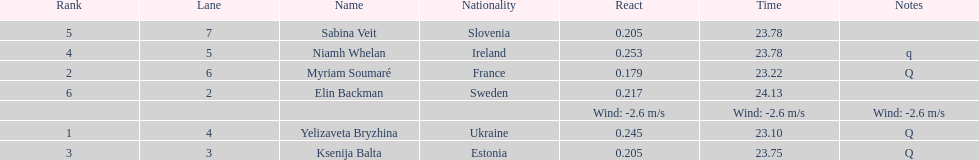Would you mind parsing the complete table? {'header': ['Rank', 'Lane', 'Name', 'Nationality', 'React', 'Time', 'Notes'], 'rows': [['5', '7', 'Sabina Veit', 'Slovenia', '0.205', '23.78', ''], ['4', '5', 'Niamh Whelan', 'Ireland', '0.253', '23.78', 'q'], ['2', '6', 'Myriam Soumaré', 'France', '0.179', '23.22', 'Q'], ['6', '2', 'Elin Backman', 'Sweden', '0.217', '24.13', ''], ['', '', '', '', 'Wind: -2.6\xa0m/s', 'Wind: -2.6\xa0m/s', 'Wind: -2.6\xa0m/s'], ['1', '4', 'Yelizaveta Bryzhina', 'Ukraine', '0.245', '23.10', 'Q'], ['3', '3', 'Ksenija Balta', 'Estonia', '0.205', '23.75', 'Q']]} What number of last names start with "b"? 3. 